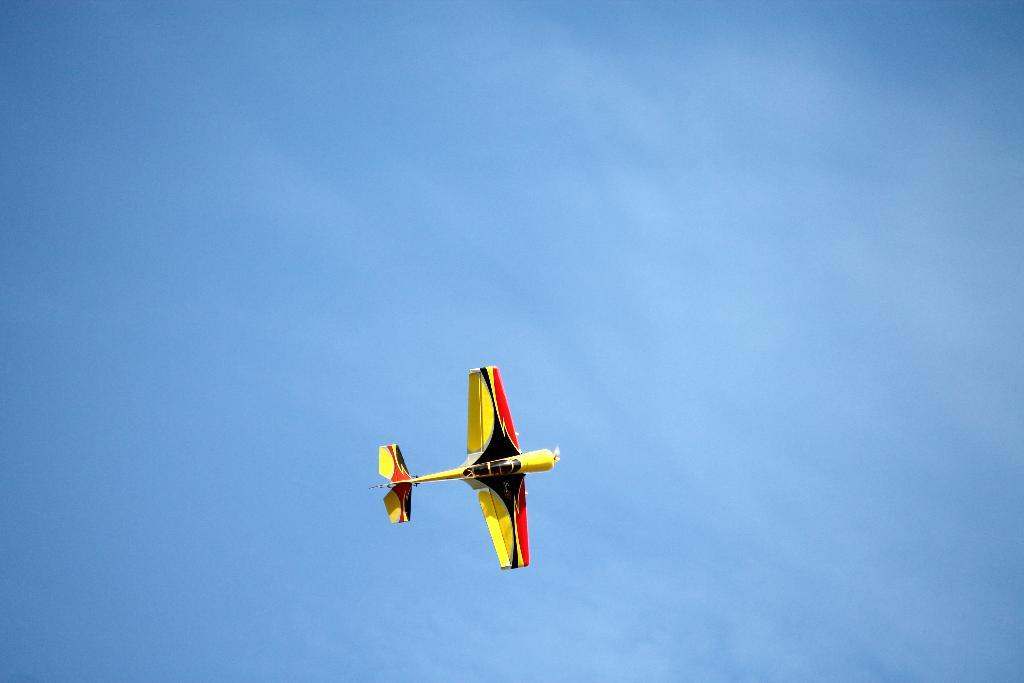What is the main subject of the image? The main subject of the image is an airplane. Where is the airplane located in the image? The airplane is in the air in the image. What can be seen in the background of the image? The sky is visible in the image. What is the color of the sky in the image? The color of the sky in the image is blue. How many toes can be seen on the airplane in the image? There are no toes visible on the airplane in the image, as it is a vehicle and not a living being. 